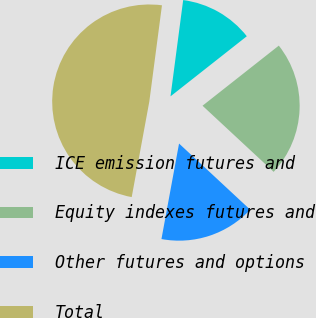<chart> <loc_0><loc_0><loc_500><loc_500><pie_chart><fcel>ICE emission futures and<fcel>Equity indexes futures and<fcel>Other futures and options<fcel>Total<nl><fcel>12.3%<fcel>22.54%<fcel>15.98%<fcel>49.18%<nl></chart> 